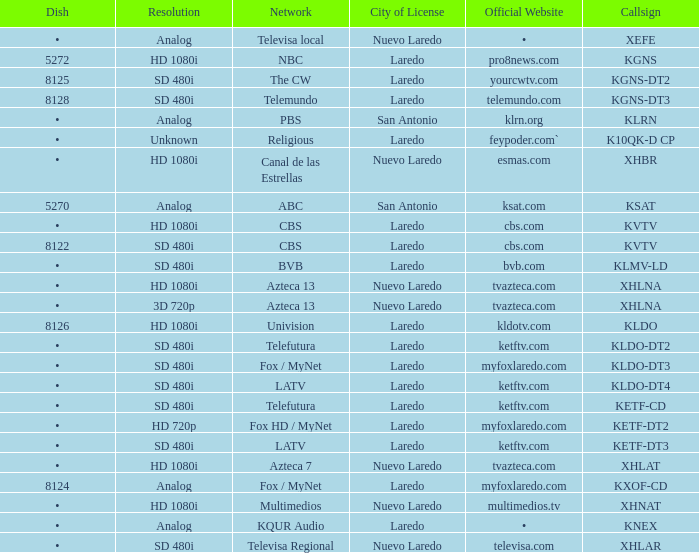Name the resolution with dish of 8126 HD 1080i. 